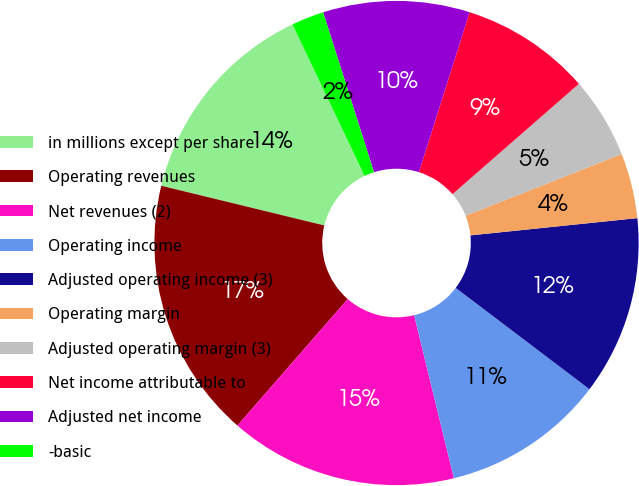Convert chart. <chart><loc_0><loc_0><loc_500><loc_500><pie_chart><fcel>in millions except per share<fcel>Operating revenues<fcel>Net revenues (2)<fcel>Operating income<fcel>Adjusted operating income (3)<fcel>Operating margin<fcel>Adjusted operating margin (3)<fcel>Net income attributable to<fcel>Adjusted net income<fcel>-basic<nl><fcel>14.13%<fcel>17.39%<fcel>15.22%<fcel>10.87%<fcel>11.96%<fcel>4.35%<fcel>5.43%<fcel>8.7%<fcel>9.78%<fcel>2.17%<nl></chart> 